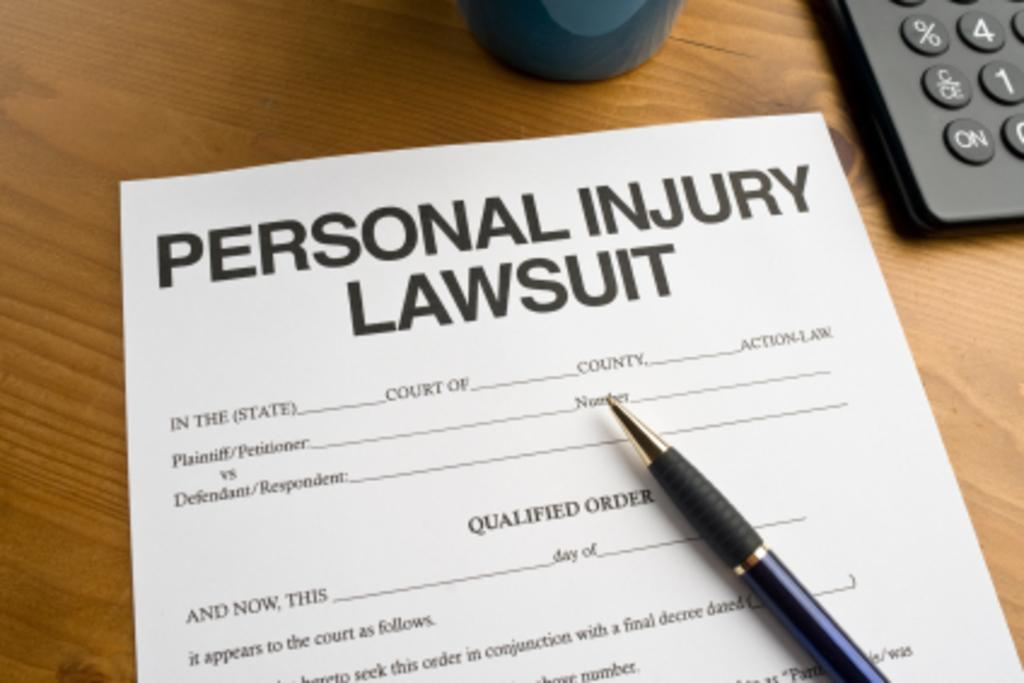<image>
Share a concise interpretation of the image provided. A pen rests on a Personal Injury Lawsuit form. 